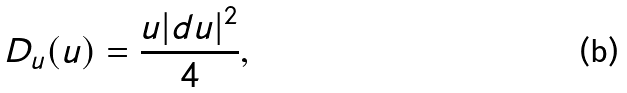<formula> <loc_0><loc_0><loc_500><loc_500>D _ { u } ( u ) = \frac { u | d u | ^ { 2 } } { 4 } ,</formula> 